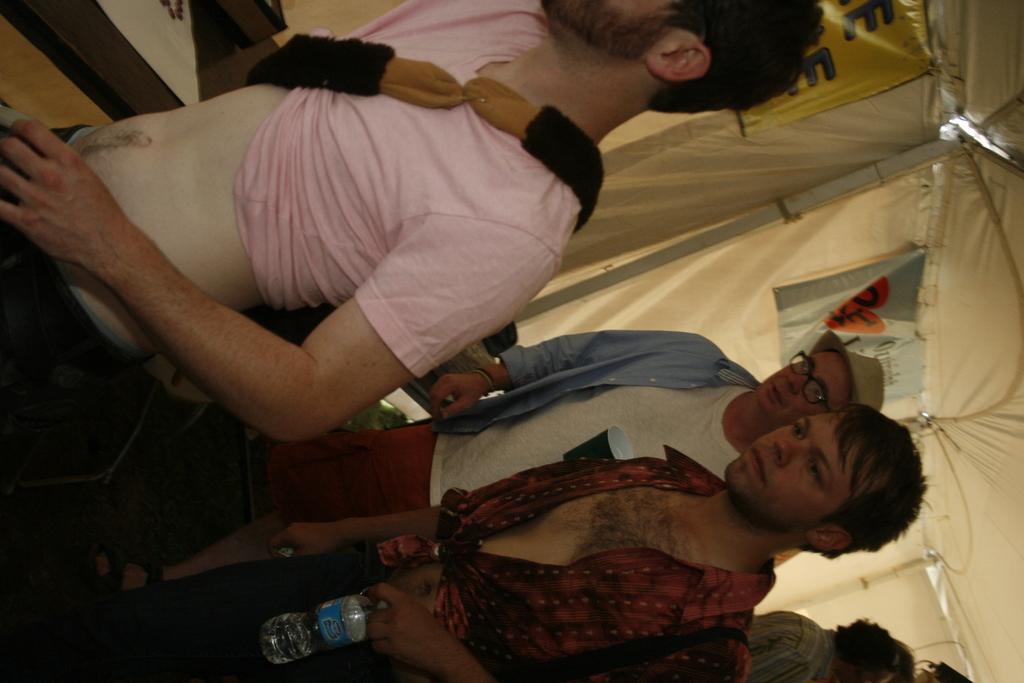How would you summarize this image in a sentence or two? In the center of the image there are persons walking. 